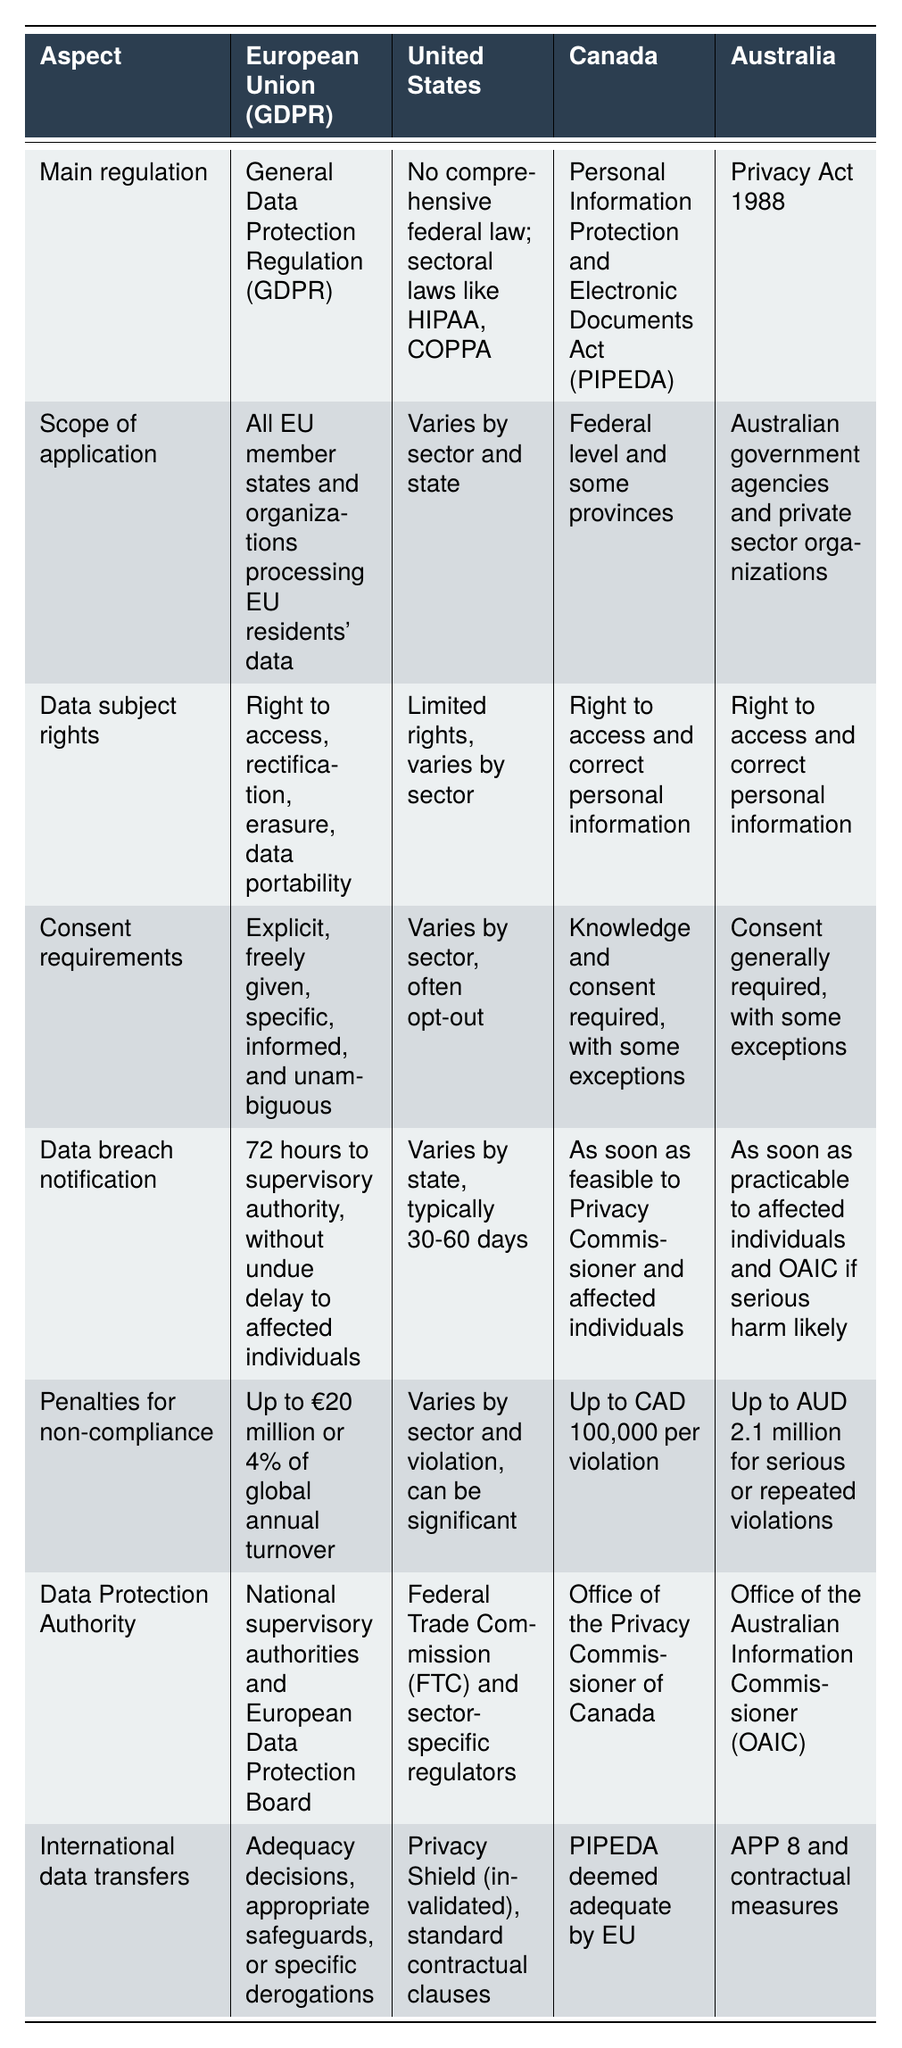What is the main regulation governing data protection in the European Union? The table states that the main regulation in the European Union is the General Data Protection Regulation (GDPR).
Answer: General Data Protection Regulation (GDPR) Which country has a comprehensive federal data protection law? The table indicates that the United States does not have a comprehensive federal law, while both Canada and Australia have comprehensive laws (PIPEDA and Privacy Act, respectively).
Answer: Canada and Australia In terms of data subject rights, which regions provide the right to erasure? According to the data, only the European Union (GDPR) explicitly lists the right to erasure among its data subject rights, while the United States has limited rights and Canada and Australia only have rights to access and correct personal information.
Answer: European Union (GDPR) How does the data breach notification period in the European Union compare to that of Canada? The table shows that the European Union requires notification within 72 hours, whereas Canada requires it as soon as feasible. This indicates that the EU has a stricter and shorter timeframe for breach notifications.
Answer: EU requires 72 hours, Canada "as soon as feasible" What is the penalty for non-compliance in Canada compared to the European Union? The table specifies that Canada has penalties of up to CAD 100,000 per violation, while the EU can impose penalties of up to €20 million or 4% of global annual turnover, making EU penalties generally more severe.
Answer: EU penalties are stricter Is it true that all countries listed have a data protection authority? The data indicates that all regions mentioned in the table—EU, US, Canada, and Australia—do have established data protection authorities. Therefore, the statement is true.
Answer: Yes 